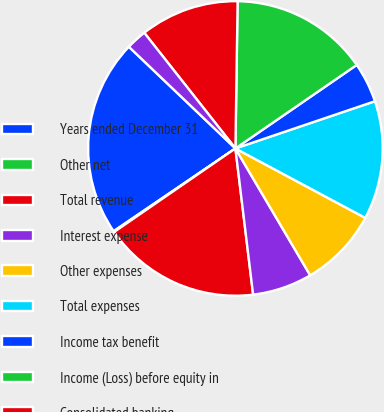<chart> <loc_0><loc_0><loc_500><loc_500><pie_chart><fcel>Years ended December 31<fcel>Other net<fcel>Total revenue<fcel>Interest expense<fcel>Other expenses<fcel>Total expenses<fcel>Income tax benefit<fcel>Income (Loss) before equity in<fcel>Consolidated banking<fcel>Consolidated non-banking<nl><fcel>21.63%<fcel>0.1%<fcel>17.32%<fcel>6.56%<fcel>8.71%<fcel>13.01%<fcel>4.4%<fcel>15.17%<fcel>10.86%<fcel>2.25%<nl></chart> 